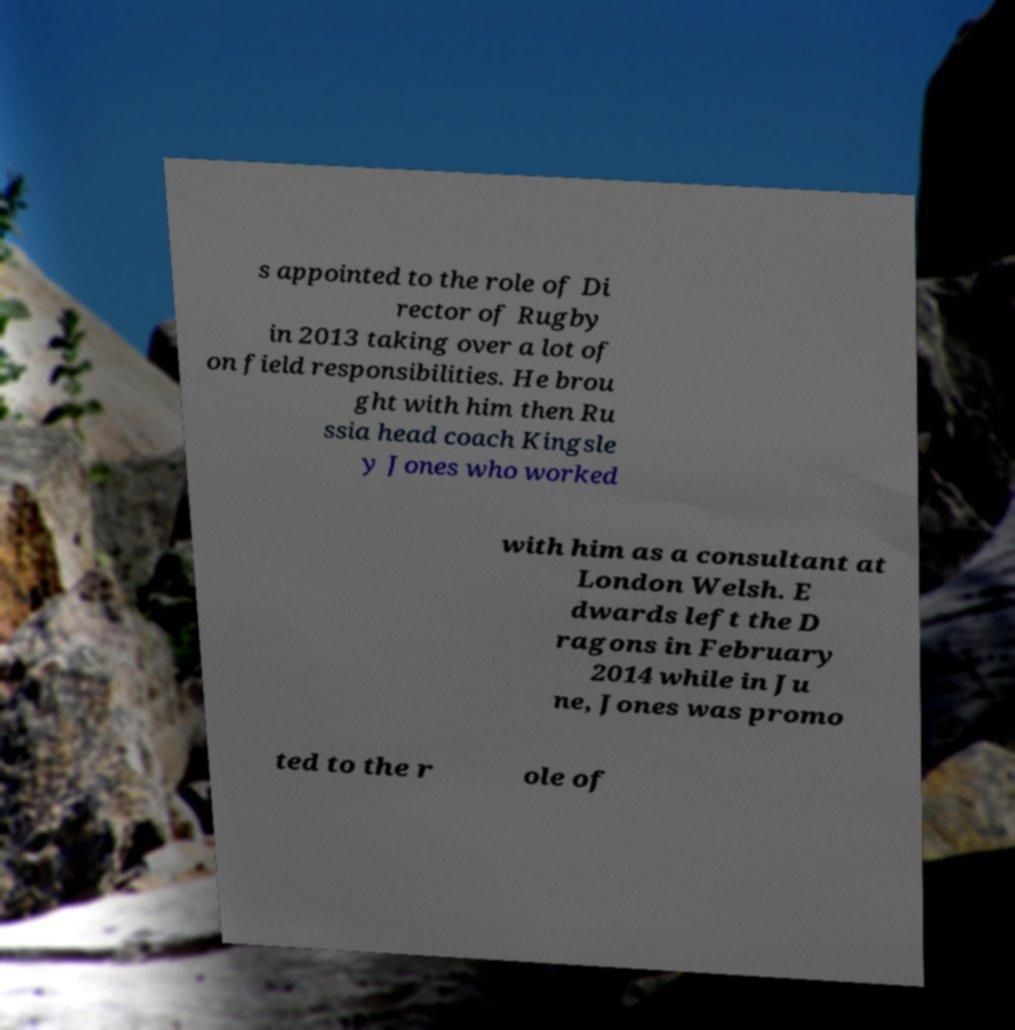There's text embedded in this image that I need extracted. Can you transcribe it verbatim? s appointed to the role of Di rector of Rugby in 2013 taking over a lot of on field responsibilities. He brou ght with him then Ru ssia head coach Kingsle y Jones who worked with him as a consultant at London Welsh. E dwards left the D ragons in February 2014 while in Ju ne, Jones was promo ted to the r ole of 